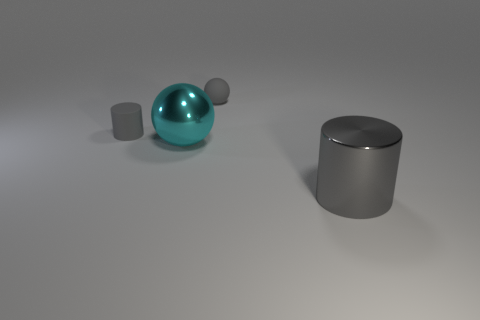What number of other objects are the same color as the tiny cylinder?
Keep it short and to the point. 2. How many other things are made of the same material as the small cylinder?
Provide a succinct answer. 1. Do the cyan metallic ball and the cylinder to the left of the gray shiny object have the same size?
Your answer should be very brief. No. What color is the big metal ball?
Make the answer very short. Cyan. The big thing behind the thing right of the tiny gray thing on the right side of the small rubber cylinder is what shape?
Provide a short and direct response. Sphere. There is a gray cylinder that is behind the large object that is behind the large gray cylinder; what is it made of?
Ensure brevity in your answer.  Rubber. What shape is the gray object that is made of the same material as the cyan thing?
Make the answer very short. Cylinder. Is there anything else that is the same shape as the big cyan metallic object?
Your answer should be very brief. Yes. There is a cyan sphere; what number of rubber objects are left of it?
Give a very brief answer. 1. Are there any cyan spheres?
Give a very brief answer. Yes. 